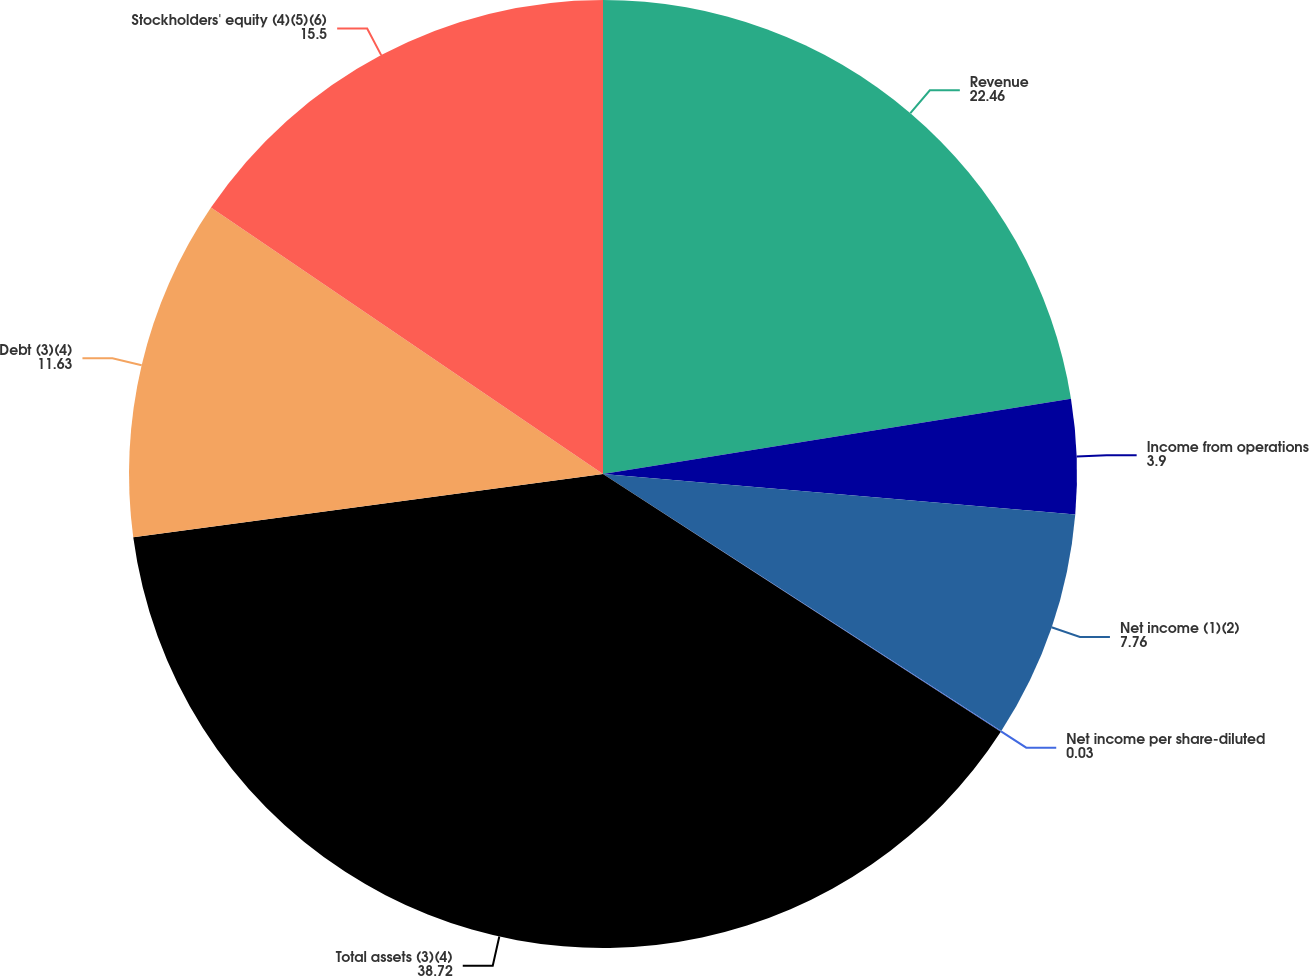Convert chart to OTSL. <chart><loc_0><loc_0><loc_500><loc_500><pie_chart><fcel>Revenue<fcel>Income from operations<fcel>Net income (1)(2)<fcel>Net income per share-diluted<fcel>Total assets (3)(4)<fcel>Debt (3)(4)<fcel>Stockholders' equity (4)(5)(6)<nl><fcel>22.46%<fcel>3.9%<fcel>7.76%<fcel>0.03%<fcel>38.72%<fcel>11.63%<fcel>15.5%<nl></chart> 